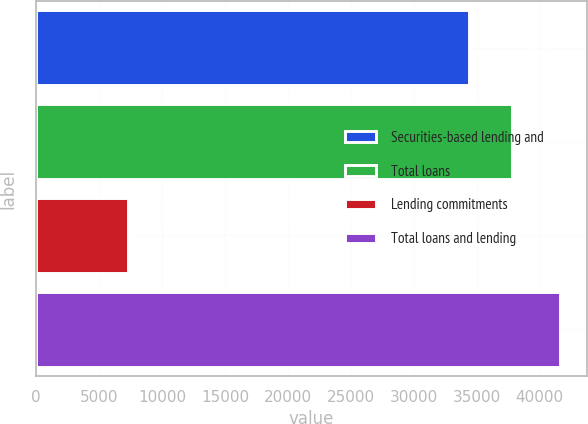<chart> <loc_0><loc_0><loc_500><loc_500><bar_chart><fcel>Securities-based lending and<fcel>Total loans<fcel>Lending commitments<fcel>Total loans and lending<nl><fcel>34389<fcel>37827.9<fcel>7253<fcel>41642<nl></chart> 